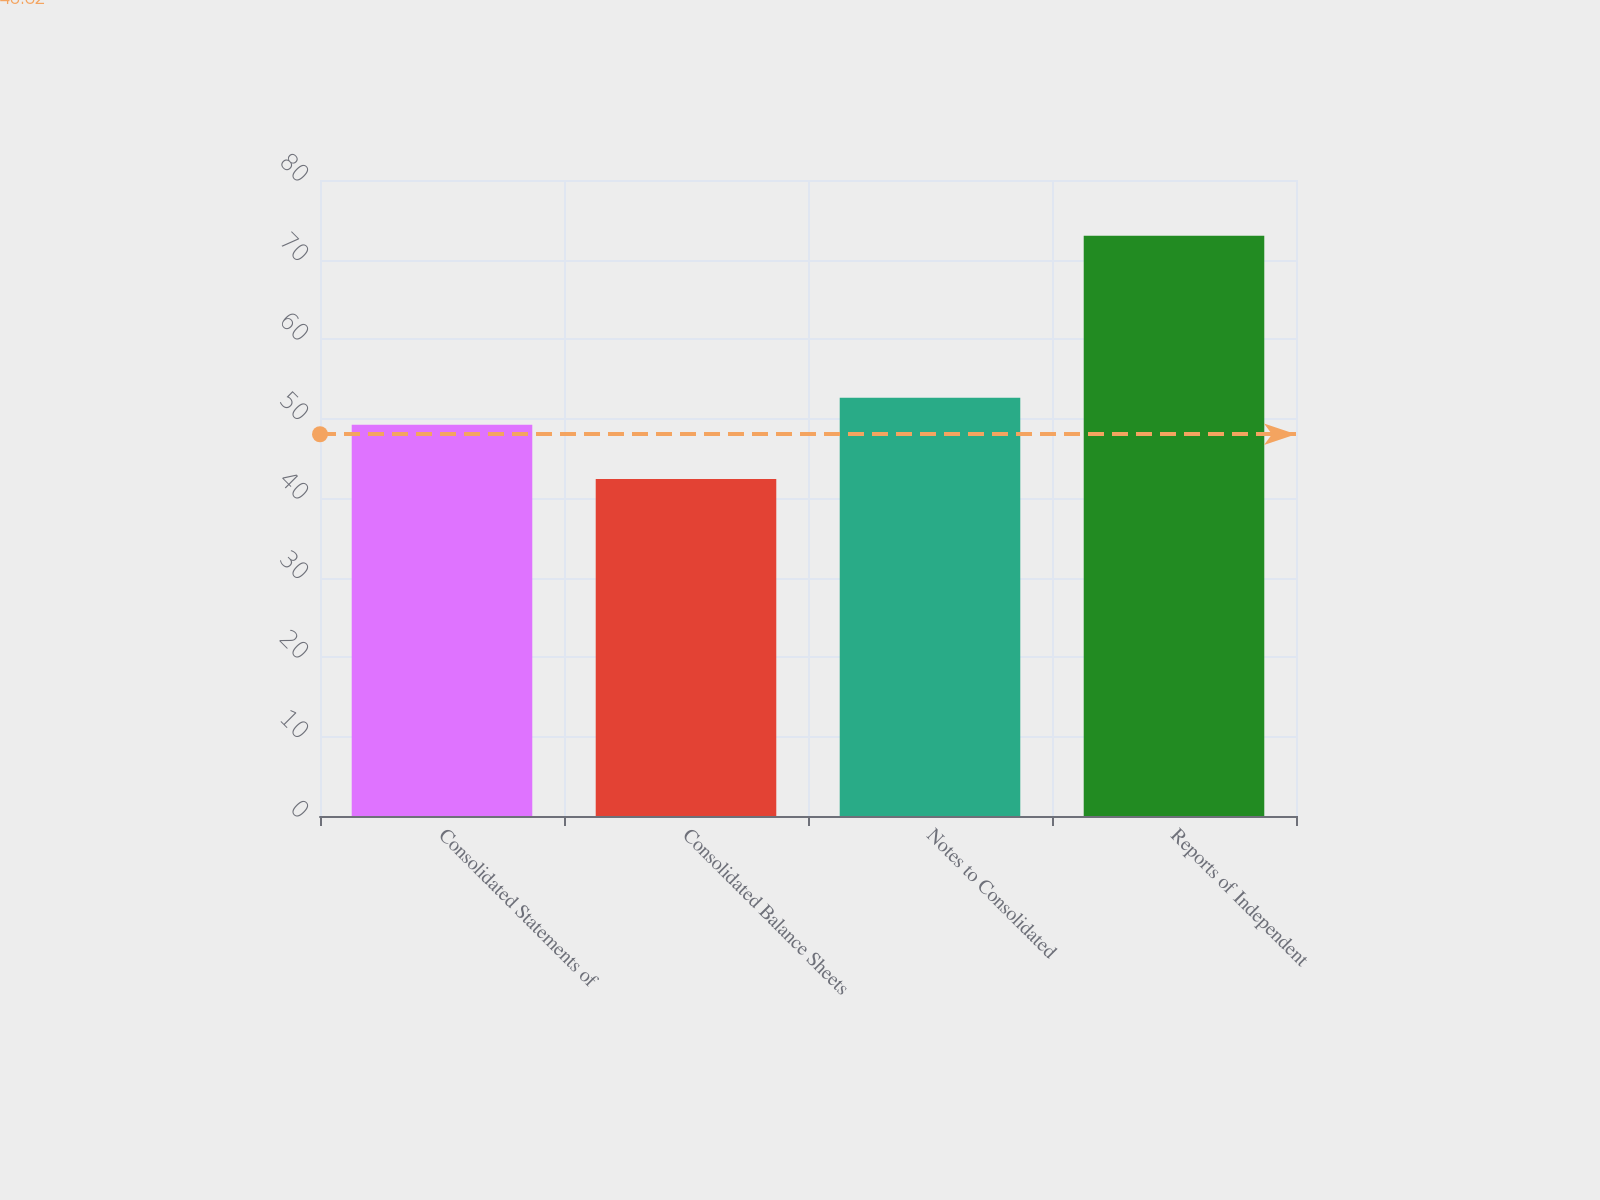Convert chart. <chart><loc_0><loc_0><loc_500><loc_500><bar_chart><fcel>Consolidated Statements of<fcel>Consolidated Balance Sheets<fcel>Notes to Consolidated<fcel>Reports of Independent<nl><fcel>49.2<fcel>42.4<fcel>52.6<fcel>73<nl></chart> 